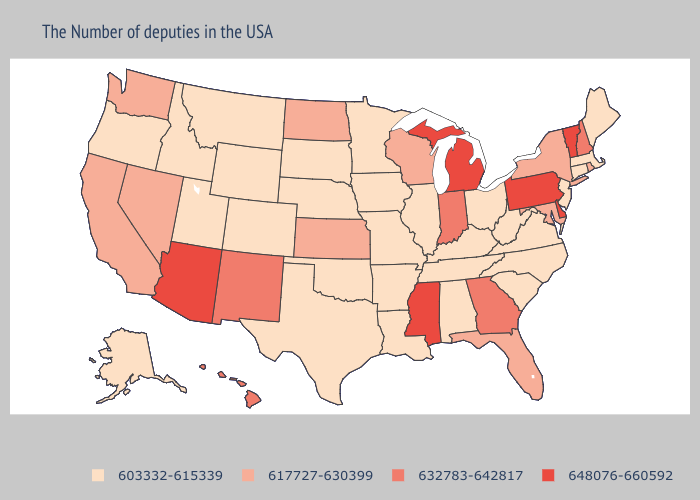Which states have the highest value in the USA?
Be succinct. Vermont, Delaware, Pennsylvania, Michigan, Mississippi, Arizona. Does Alabama have the highest value in the South?
Answer briefly. No. Among the states that border North Dakota , which have the highest value?
Quick response, please. Minnesota, South Dakota, Montana. Does Arizona have the highest value in the USA?
Be succinct. Yes. Name the states that have a value in the range 648076-660592?
Keep it brief. Vermont, Delaware, Pennsylvania, Michigan, Mississippi, Arizona. Does Kansas have a lower value than Montana?
Give a very brief answer. No. Does Maine have the lowest value in the USA?
Write a very short answer. Yes. Name the states that have a value in the range 603332-615339?
Concise answer only. Maine, Massachusetts, Connecticut, New Jersey, Virginia, North Carolina, South Carolina, West Virginia, Ohio, Kentucky, Alabama, Tennessee, Illinois, Louisiana, Missouri, Arkansas, Minnesota, Iowa, Nebraska, Oklahoma, Texas, South Dakota, Wyoming, Colorado, Utah, Montana, Idaho, Oregon, Alaska. What is the highest value in the USA?
Keep it brief. 648076-660592. Name the states that have a value in the range 617727-630399?
Concise answer only. Rhode Island, New York, Maryland, Florida, Wisconsin, Kansas, North Dakota, Nevada, California, Washington. Which states have the highest value in the USA?
Answer briefly. Vermont, Delaware, Pennsylvania, Michigan, Mississippi, Arizona. Among the states that border Texas , does Oklahoma have the lowest value?
Be succinct. Yes. Does Delaware have the highest value in the USA?
Answer briefly. Yes. Does Louisiana have a lower value than Arizona?
Concise answer only. Yes. Which states hav the highest value in the MidWest?
Concise answer only. Michigan. 